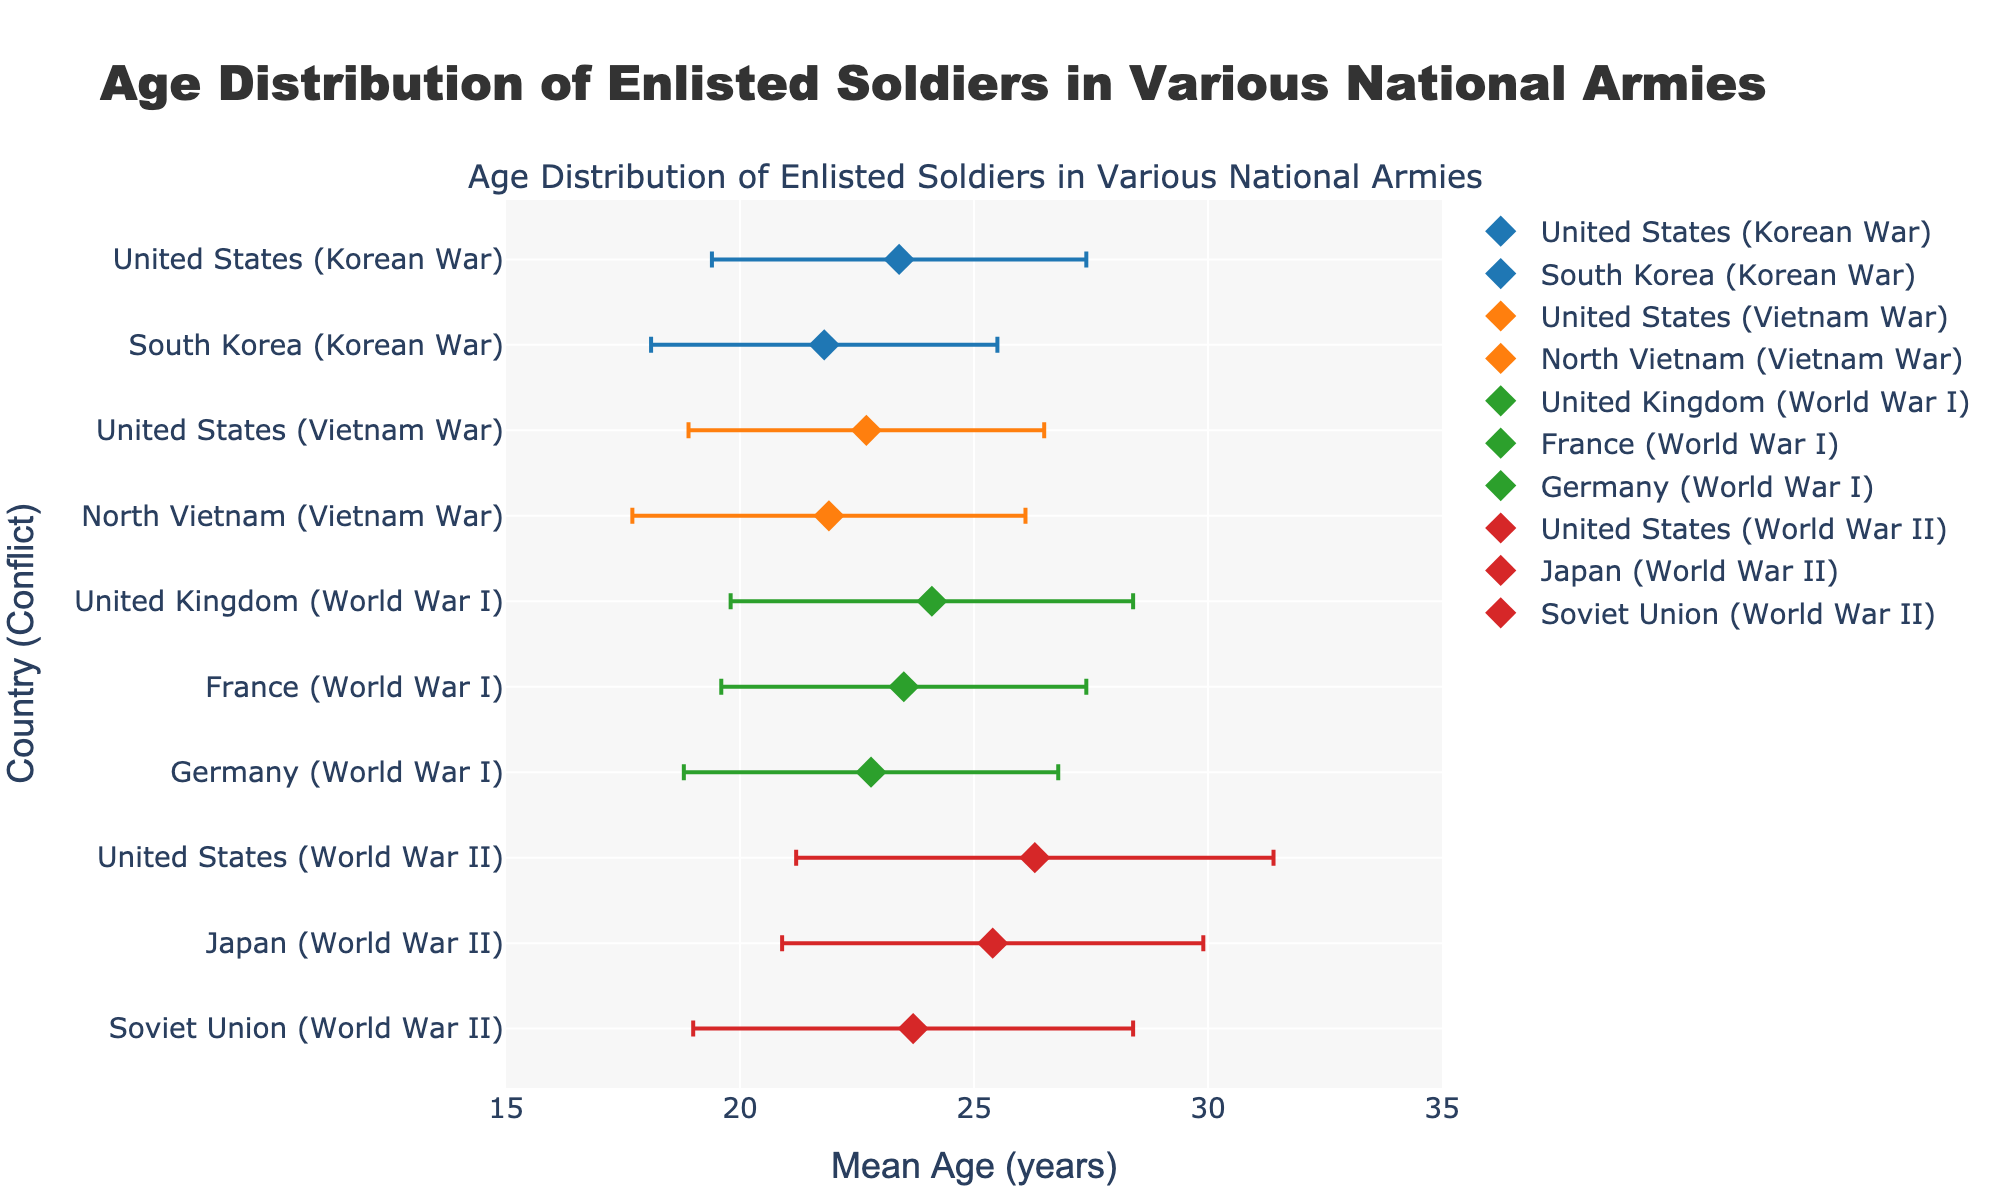What is the title of the figure? The title of the figure is the text displayed at the top of the plot. It gives an overview of what the plot is about. In this case, it reads "Age Distribution of Enlisted Soldiers in Various National Armies".
Answer: Age Distribution of Enlisted Soldiers in Various National Armies Which country has the highest mean age for enlisted soldiers during World War II? To find the highest mean age during World War II, compare the 'mean age' values for the United States, Japan, and the Soviet Union. The United States has the highest mean age of 26.3 years.
Answer: United States How does the mean age of enlisted soldiers in the United Kingdom during World War I compare to that in the United States during the Vietnam War? Compare the mean ages of the two specified countries and conflicts. The mean age for the United Kingdom (World War I) is 24.1, and for the United States (Vietnam War), it is 22.7. Thus, the mean age is higher for the United Kingdom.
Answer: Higher for the United Kingdom What is the range of mean ages for the conflicts represented in the figure? Range is calculated by subtracting the smallest mean age from the largest mean age. The smallest mean age is 21.8 (South Korea, Korean War), and the largest is 26.3 (United States, World War II). Thus, the range is 26.3 - 21.8 = 4.5 years.
Answer: 4.5 years Which country's enlisted soldiers during the Korean War had a lower mean age, the United States or South Korea? Compare the mean ages of the two specified countries during the Korean War. The mean age for the United States is 23.4 and for South Korea, it is 21.8. Thus, enlisted soldiers in South Korea had a lower mean age.
Answer: South Korea What is the standard deviation in mean age for German soldiers during World War I? The standard deviation is given directly in the plot’s hover information for each data point. For German soldiers during World War I, the standard deviation is 4.0.
Answer: 4.0 What is the mean age difference between Soviet Union soldiers during World War II and North Vietnam soldiers during the Vietnam War? Calculate the difference by subtracting the mean age of North Vietnam soldiers in the Vietnam War (21.9) from that of Soviet Union soldiers in World War II (23.7). The difference is 23.7 - 21.9 = 1.8 years.
Answer: 1.8 years How many countries' data points are shown for World War I? Count the number of countries listed under World War I. The countries are the United Kingdom, France, and Germany, making a total of three countries.
Answer: 3 Which conflict has the greater variability in the age of enlisted soldiers, World War II or the Korean War? Variability is indicated by the standard deviation. To find this, compare the standard deviations for the countries involved in each conflict. For World War II: United States (5.1), Japan (4.5), Soviet Union (4.7). For the Korean War: United States (4.0), South Korea (3.7). The greatest standard deviation in World War II is 5.1, while in the Korean War, it is 4.0. Thus, World War II has greater variability.
Answer: World War II 